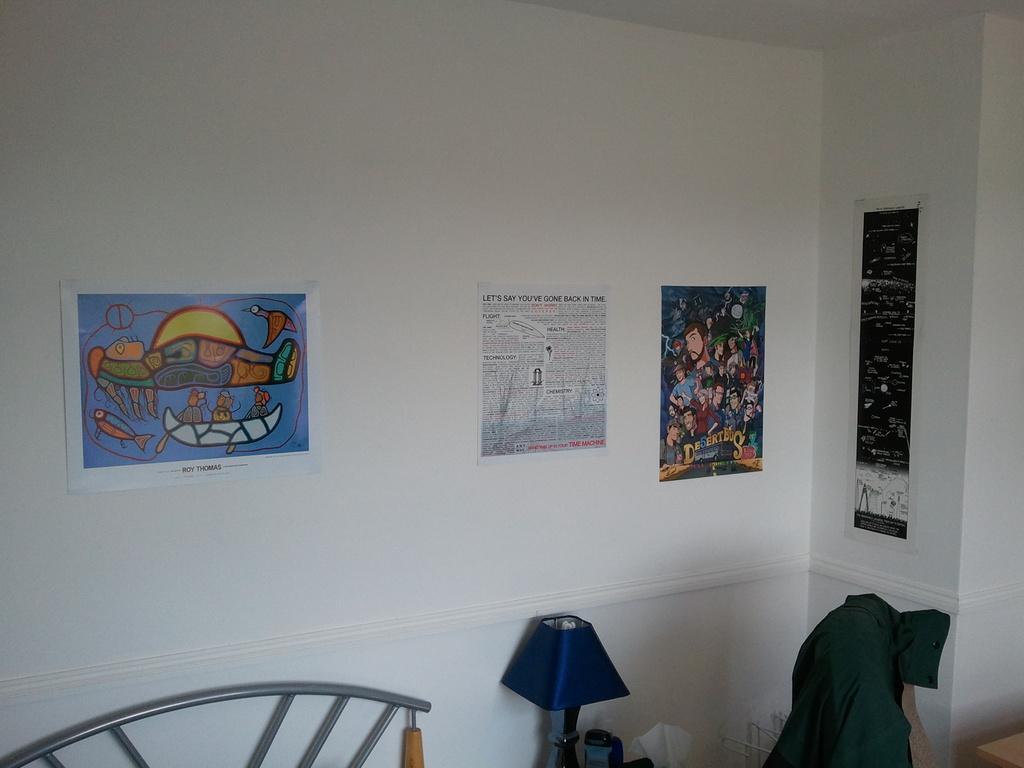In one or two sentences, can you explain what this image depicts? This picture might be taken inside the room. In this image, on the right corner, we can see one edge of the table. On the right side, we can see a cloth. In the middle of the image, we can see a lamp and a jar. On the left side, we can see a metal rod. In the background, we can see few posts which are attached to a wall. 